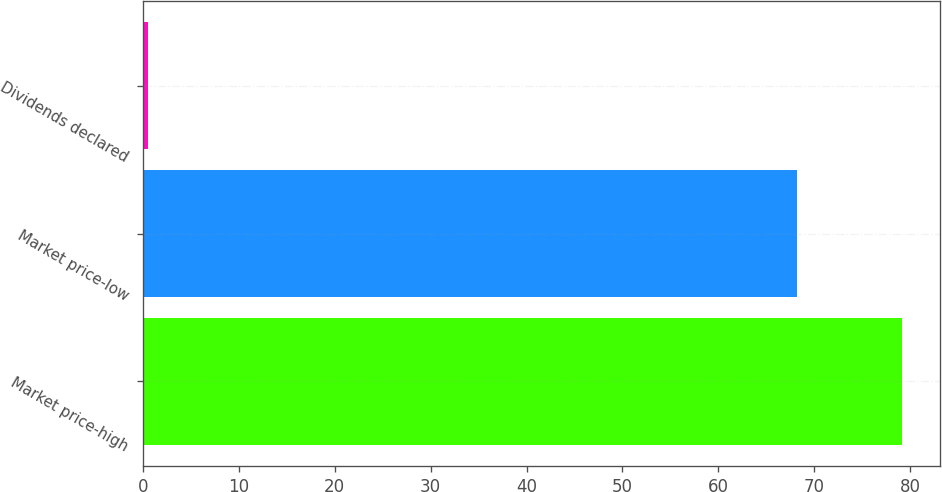Convert chart. <chart><loc_0><loc_0><loc_500><loc_500><bar_chart><fcel>Market price-high<fcel>Market price-low<fcel>Dividends declared<nl><fcel>79.16<fcel>68.18<fcel>0.57<nl></chart> 